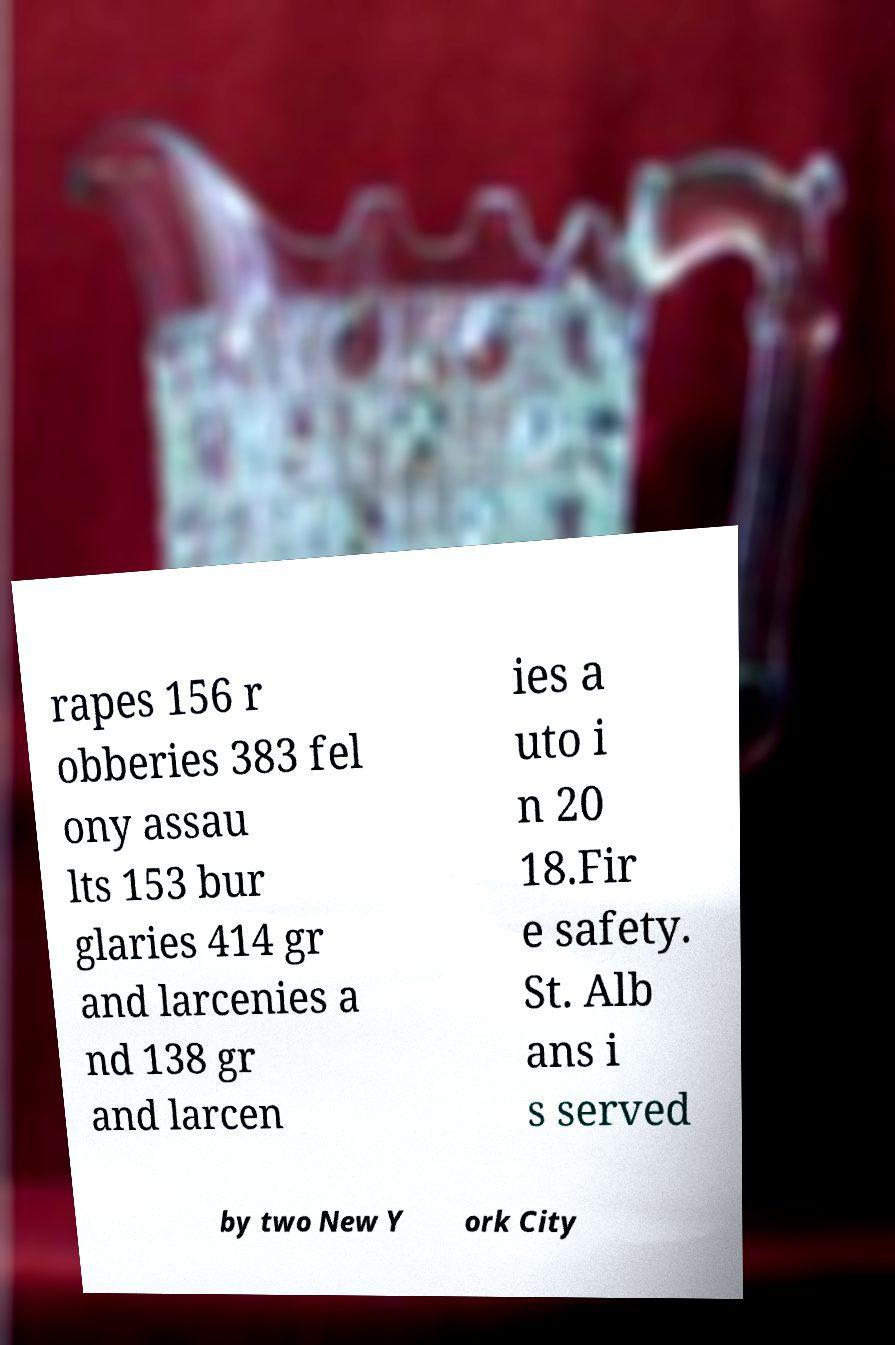Could you extract and type out the text from this image? rapes 156 r obberies 383 fel ony assau lts 153 bur glaries 414 gr and larcenies a nd 138 gr and larcen ies a uto i n 20 18.Fir e safety. St. Alb ans i s served by two New Y ork City 